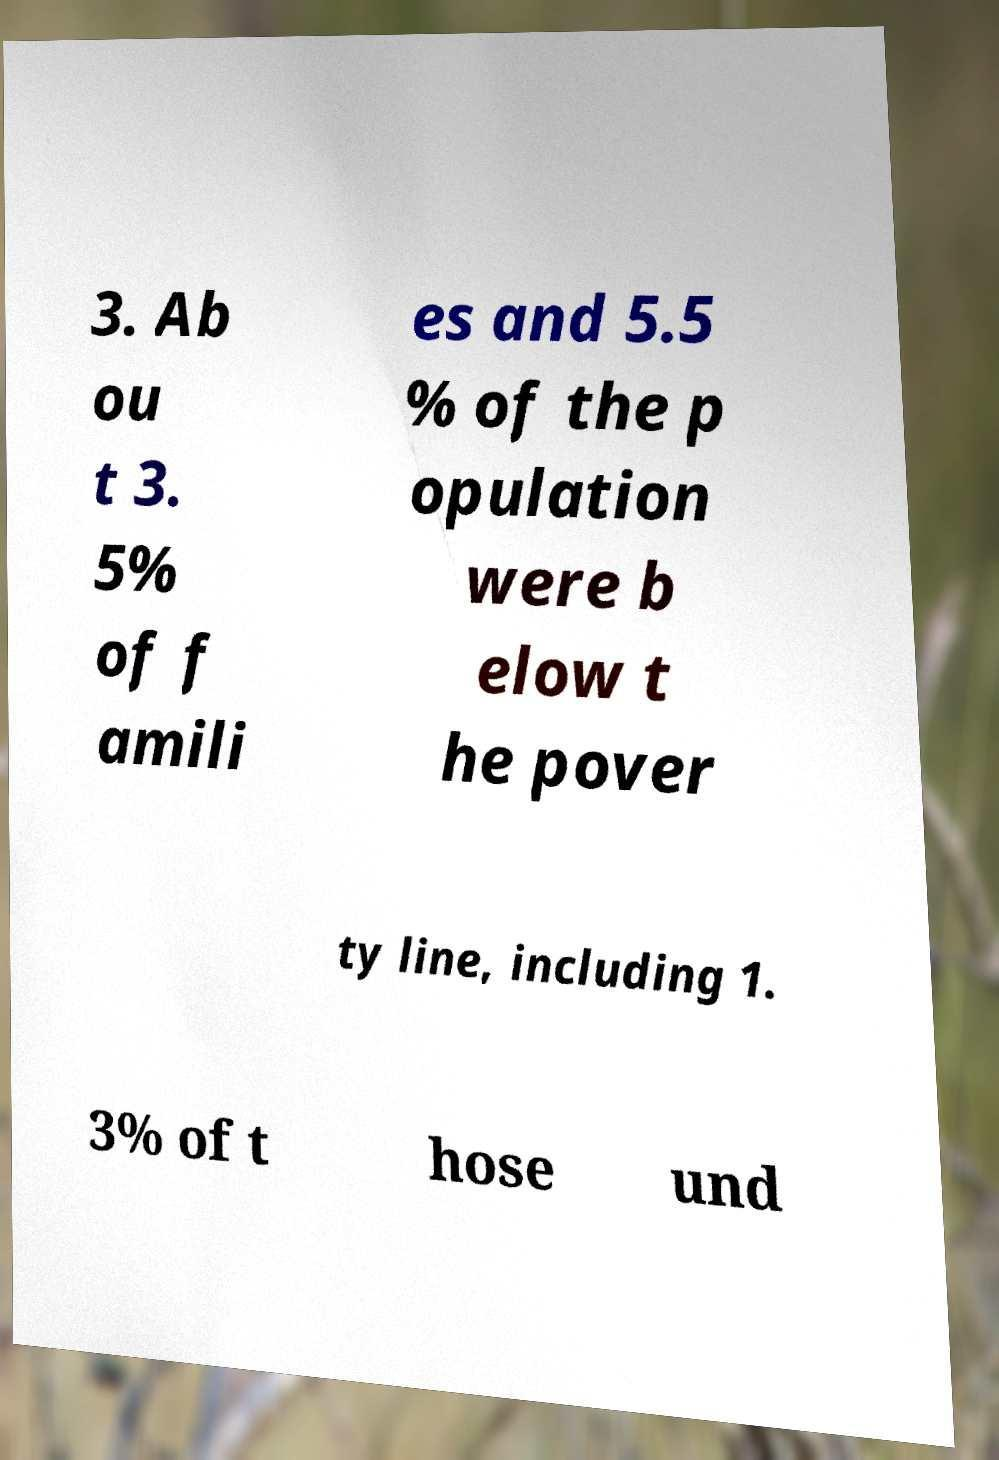Please identify and transcribe the text found in this image. 3. Ab ou t 3. 5% of f amili es and 5.5 % of the p opulation were b elow t he pover ty line, including 1. 3% of t hose und 